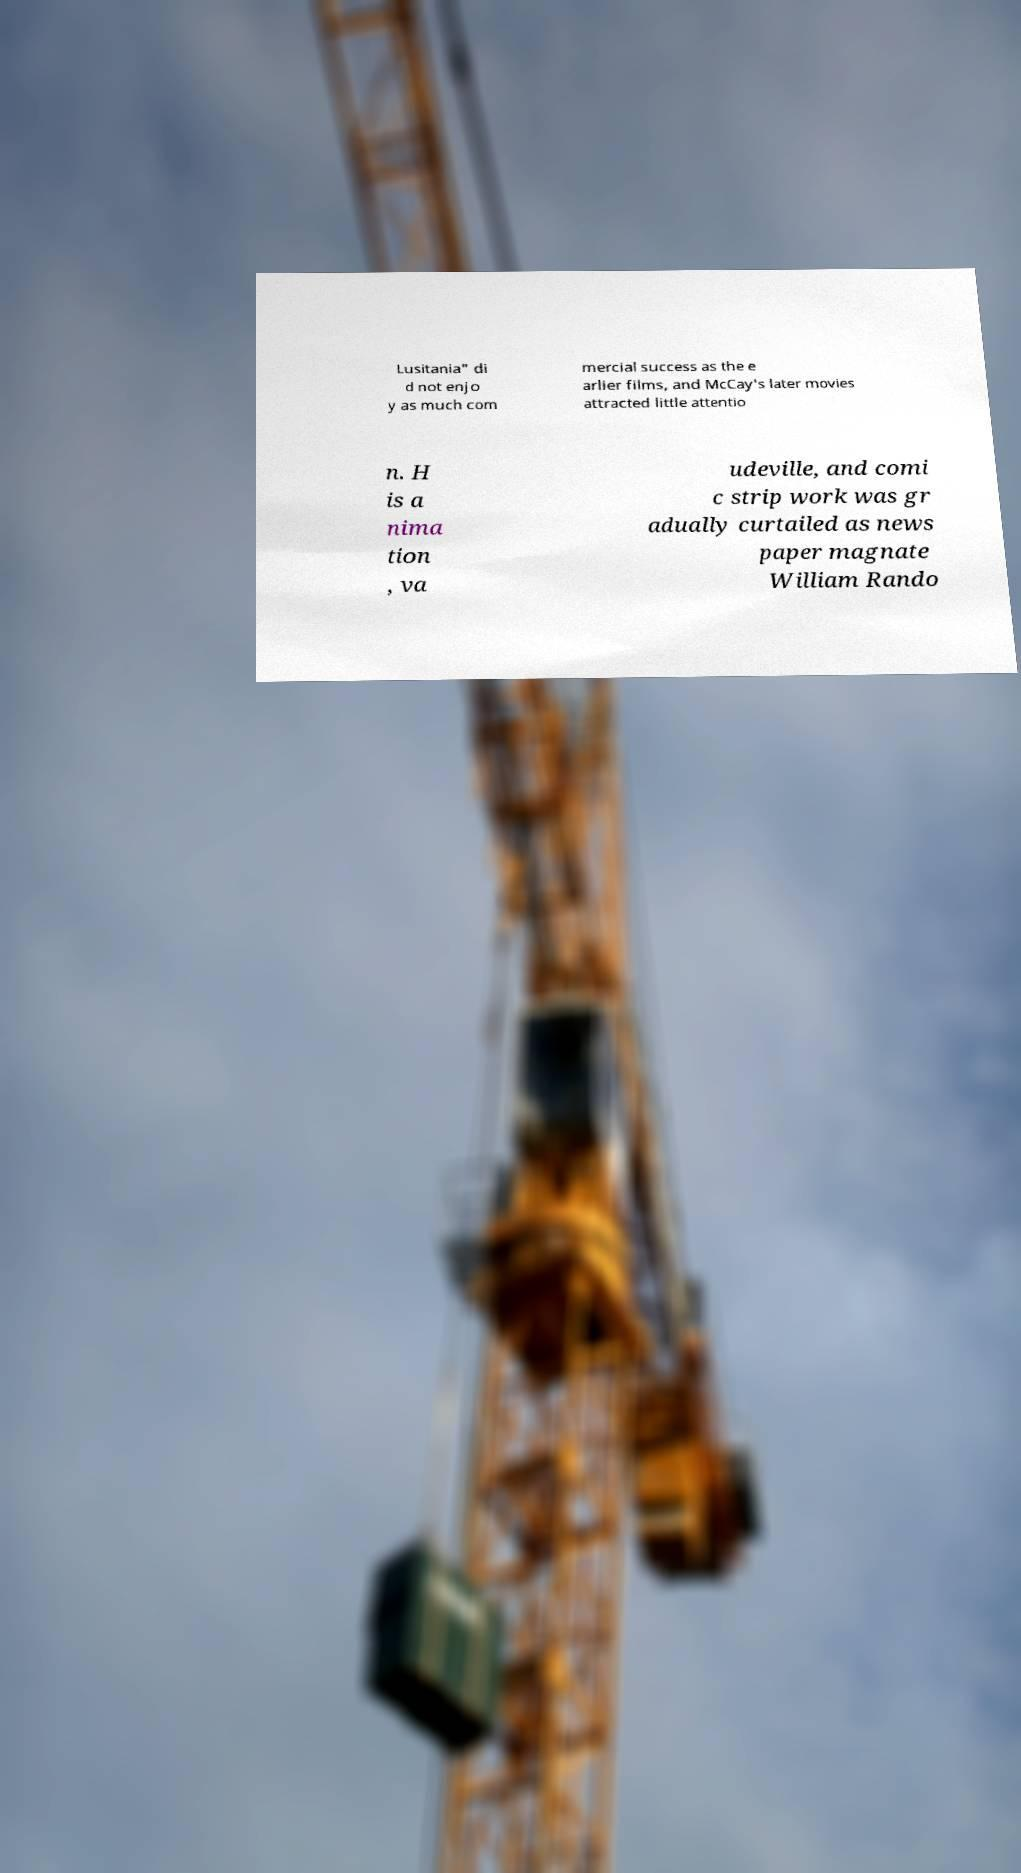There's text embedded in this image that I need extracted. Can you transcribe it verbatim? Lusitania" di d not enjo y as much com mercial success as the e arlier films, and McCay's later movies attracted little attentio n. H is a nima tion , va udeville, and comi c strip work was gr adually curtailed as news paper magnate William Rando 